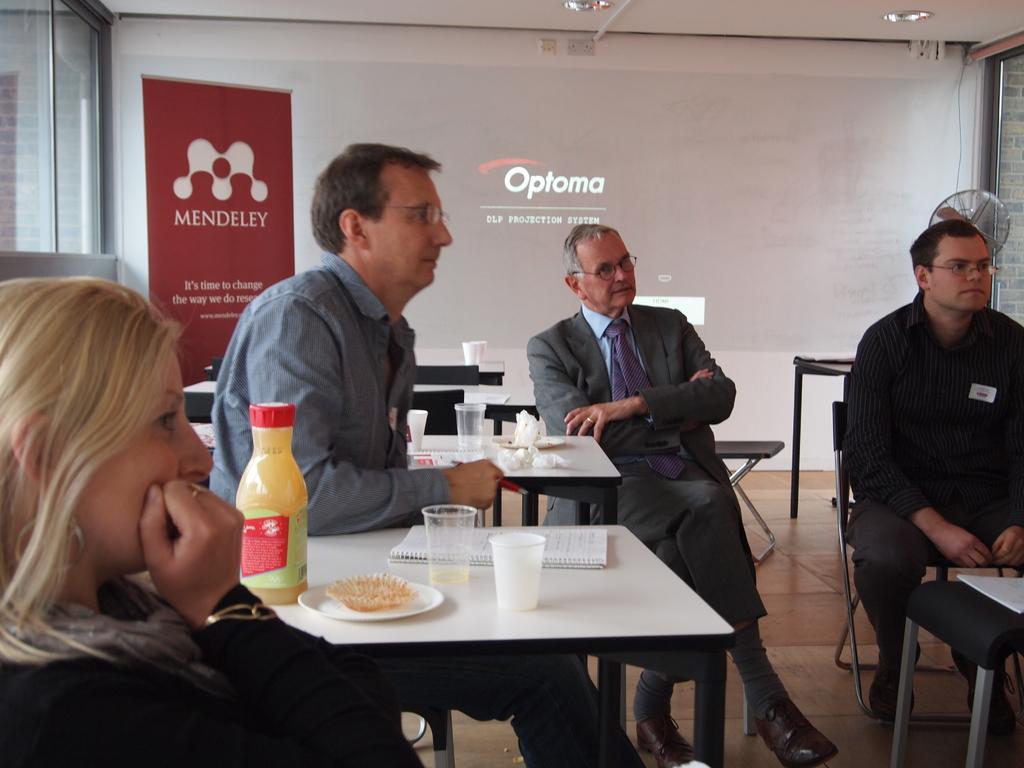Please provide a concise description of this image. This may be a picture of a meeting. In the picture on the right a man in black dress is seated in a chair. In center a man in suit is sitting. In the left a black dress woman is there. On the center left a man is seated. In this room there are many tables, cups, bottles, plates. On the top right there is a fan. There are lights to the ceiling. On the top left there is window. On the top left there is window. 